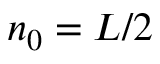Convert formula to latex. <formula><loc_0><loc_0><loc_500><loc_500>n _ { 0 } = L / 2</formula> 